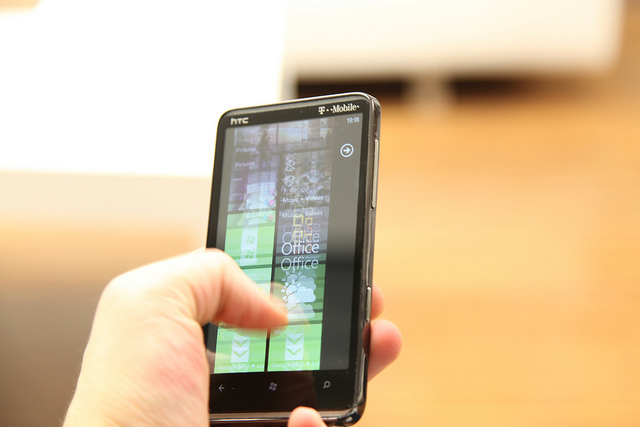Please transcribe the text information in this image. htc Mobile office Office office 